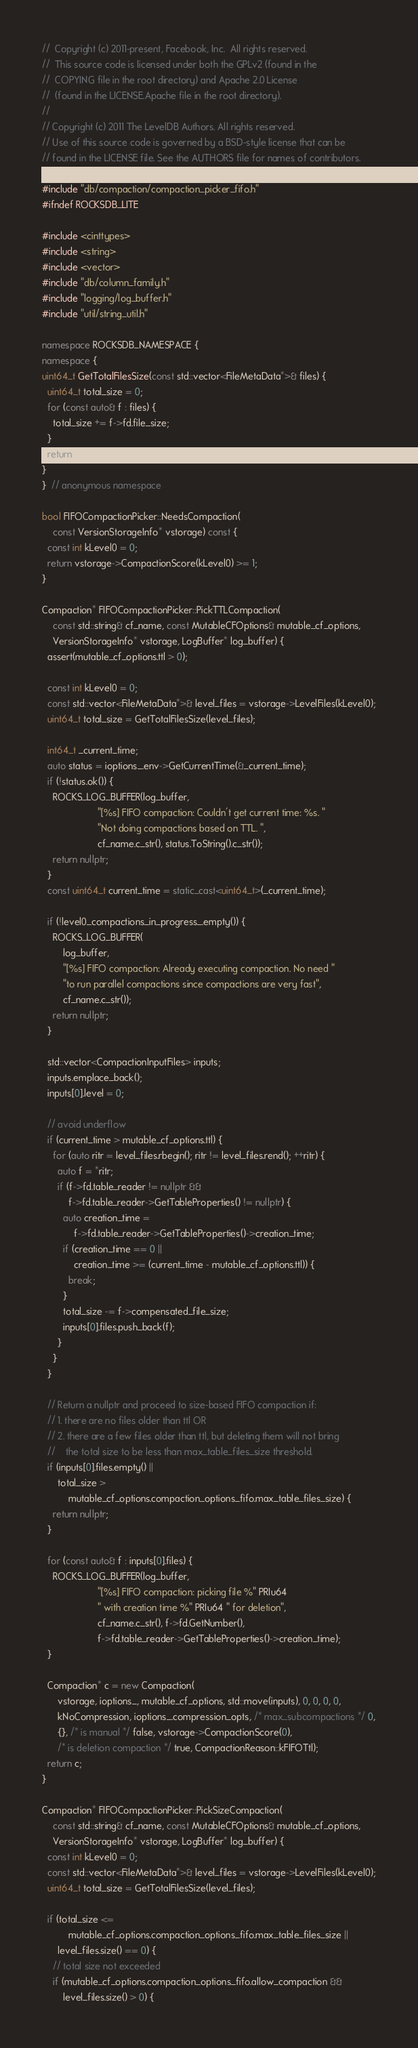<code> <loc_0><loc_0><loc_500><loc_500><_C++_>//  Copyright (c) 2011-present, Facebook, Inc.  All rights reserved.
//  This source code is licensed under both the GPLv2 (found in the
//  COPYING file in the root directory) and Apache 2.0 License
//  (found in the LICENSE.Apache file in the root directory).
//
// Copyright (c) 2011 The LevelDB Authors. All rights reserved.
// Use of this source code is governed by a BSD-style license that can be
// found in the LICENSE file. See the AUTHORS file for names of contributors.

#include "db/compaction/compaction_picker_fifo.h"
#ifndef ROCKSDB_LITE

#include <cinttypes>
#include <string>
#include <vector>
#include "db/column_family.h"
#include "logging/log_buffer.h"
#include "util/string_util.h"

namespace ROCKSDB_NAMESPACE {
namespace {
uint64_t GetTotalFilesSize(const std::vector<FileMetaData*>& files) {
  uint64_t total_size = 0;
  for (const auto& f : files) {
    total_size += f->fd.file_size;
  }
  return total_size;
}
}  // anonymous namespace

bool FIFOCompactionPicker::NeedsCompaction(
    const VersionStorageInfo* vstorage) const {
  const int kLevel0 = 0;
  return vstorage->CompactionScore(kLevel0) >= 1;
}

Compaction* FIFOCompactionPicker::PickTTLCompaction(
    const std::string& cf_name, const MutableCFOptions& mutable_cf_options,
    VersionStorageInfo* vstorage, LogBuffer* log_buffer) {
  assert(mutable_cf_options.ttl > 0);

  const int kLevel0 = 0;
  const std::vector<FileMetaData*>& level_files = vstorage->LevelFiles(kLevel0);
  uint64_t total_size = GetTotalFilesSize(level_files);

  int64_t _current_time;
  auto status = ioptions_.env->GetCurrentTime(&_current_time);
  if (!status.ok()) {
    ROCKS_LOG_BUFFER(log_buffer,
                     "[%s] FIFO compaction: Couldn't get current time: %s. "
                     "Not doing compactions based on TTL. ",
                     cf_name.c_str(), status.ToString().c_str());
    return nullptr;
  }
  const uint64_t current_time = static_cast<uint64_t>(_current_time);

  if (!level0_compactions_in_progress_.empty()) {
    ROCKS_LOG_BUFFER(
        log_buffer,
        "[%s] FIFO compaction: Already executing compaction. No need "
        "to run parallel compactions since compactions are very fast",
        cf_name.c_str());
    return nullptr;
  }

  std::vector<CompactionInputFiles> inputs;
  inputs.emplace_back();
  inputs[0].level = 0;

  // avoid underflow
  if (current_time > mutable_cf_options.ttl) {
    for (auto ritr = level_files.rbegin(); ritr != level_files.rend(); ++ritr) {
      auto f = *ritr;
      if (f->fd.table_reader != nullptr &&
          f->fd.table_reader->GetTableProperties() != nullptr) {
        auto creation_time =
            f->fd.table_reader->GetTableProperties()->creation_time;
        if (creation_time == 0 ||
            creation_time >= (current_time - mutable_cf_options.ttl)) {
          break;
        }
        total_size -= f->compensated_file_size;
        inputs[0].files.push_back(f);
      }
    }
  }

  // Return a nullptr and proceed to size-based FIFO compaction if:
  // 1. there are no files older than ttl OR
  // 2. there are a few files older than ttl, but deleting them will not bring
  //    the total size to be less than max_table_files_size threshold.
  if (inputs[0].files.empty() ||
      total_size >
          mutable_cf_options.compaction_options_fifo.max_table_files_size) {
    return nullptr;
  }

  for (const auto& f : inputs[0].files) {
    ROCKS_LOG_BUFFER(log_buffer,
                     "[%s] FIFO compaction: picking file %" PRIu64
                     " with creation time %" PRIu64 " for deletion",
                     cf_name.c_str(), f->fd.GetNumber(),
                     f->fd.table_reader->GetTableProperties()->creation_time);
  }

  Compaction* c = new Compaction(
      vstorage, ioptions_, mutable_cf_options, std::move(inputs), 0, 0, 0, 0,
      kNoCompression, ioptions_.compression_opts, /* max_subcompactions */ 0,
      {}, /* is manual */ false, vstorage->CompactionScore(0),
      /* is deletion compaction */ true, CompactionReason::kFIFOTtl);
  return c;
}

Compaction* FIFOCompactionPicker::PickSizeCompaction(
    const std::string& cf_name, const MutableCFOptions& mutable_cf_options,
    VersionStorageInfo* vstorage, LogBuffer* log_buffer) {
  const int kLevel0 = 0;
  const std::vector<FileMetaData*>& level_files = vstorage->LevelFiles(kLevel0);
  uint64_t total_size = GetTotalFilesSize(level_files);

  if (total_size <=
          mutable_cf_options.compaction_options_fifo.max_table_files_size ||
      level_files.size() == 0) {
    // total size not exceeded
    if (mutable_cf_options.compaction_options_fifo.allow_compaction &&
        level_files.size() > 0) {</code> 